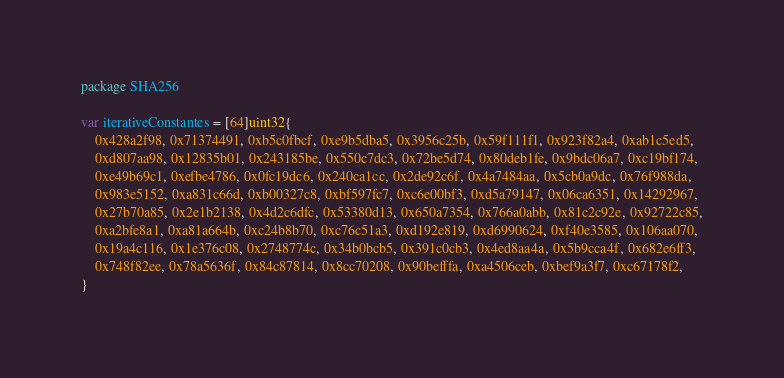Convert code to text. <code><loc_0><loc_0><loc_500><loc_500><_Go_>package SHA256

var iterativeConstantes = [64]uint32{
	0x428a2f98, 0x71374491, 0xb5c0fbcf, 0xe9b5dba5, 0x3956c25b, 0x59f111f1, 0x923f82a4, 0xab1c5ed5,
	0xd807aa98, 0x12835b01, 0x243185be, 0x550c7dc3, 0x72be5d74, 0x80deb1fe, 0x9bdc06a7, 0xc19bf174,
	0xe49b69c1, 0xefbe4786, 0x0fc19dc6, 0x240ca1cc, 0x2de92c6f, 0x4a7484aa, 0x5cb0a9dc, 0x76f988da,
	0x983e5152, 0xa831c66d, 0xb00327c8, 0xbf597fc7, 0xc6e00bf3, 0xd5a79147, 0x06ca6351, 0x14292967,
	0x27b70a85, 0x2e1b2138, 0x4d2c6dfc, 0x53380d13, 0x650a7354, 0x766a0abb, 0x81c2c92e, 0x92722c85,
	0xa2bfe8a1, 0xa81a664b, 0xc24b8b70, 0xc76c51a3, 0xd192e819, 0xd6990624, 0xf40e3585, 0x106aa070,
	0x19a4c116, 0x1e376c08, 0x2748774c, 0x34b0bcb5, 0x391c0cb3, 0x4ed8aa4a, 0x5b9cca4f, 0x682e6ff3,
	0x748f82ee, 0x78a5636f, 0x84c87814, 0x8cc70208, 0x90befffa, 0xa4506ceb, 0xbef9a3f7, 0xc67178f2,
}</code> 